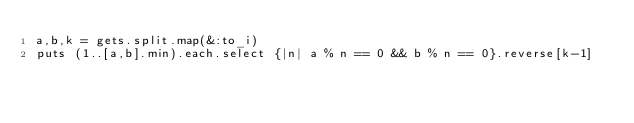Convert code to text. <code><loc_0><loc_0><loc_500><loc_500><_Ruby_>a,b,k = gets.split.map(&:to_i)
puts (1..[a,b].min).each.select {|n| a % n == 0 && b % n == 0}.reverse[k-1]</code> 